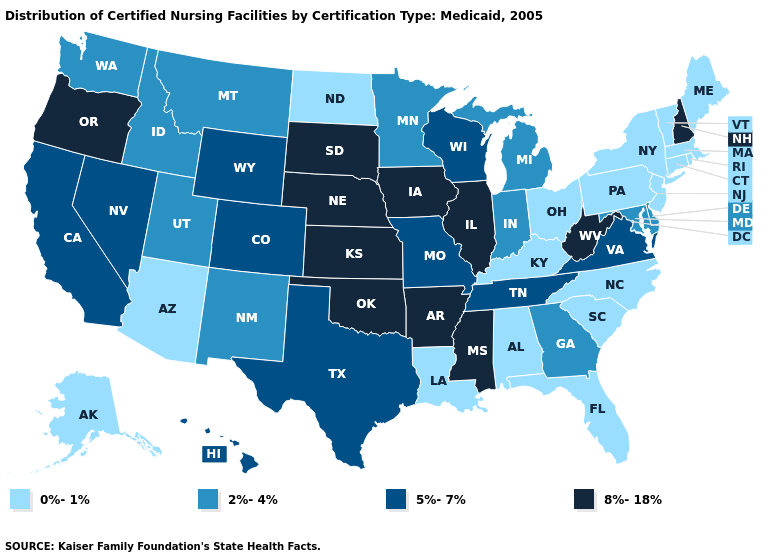Among the states that border Iowa , which have the highest value?
Write a very short answer. Illinois, Nebraska, South Dakota. Name the states that have a value in the range 5%-7%?
Short answer required. California, Colorado, Hawaii, Missouri, Nevada, Tennessee, Texas, Virginia, Wisconsin, Wyoming. Name the states that have a value in the range 8%-18%?
Quick response, please. Arkansas, Illinois, Iowa, Kansas, Mississippi, Nebraska, New Hampshire, Oklahoma, Oregon, South Dakota, West Virginia. What is the highest value in states that border Washington?
Concise answer only. 8%-18%. What is the highest value in states that border Delaware?
Be succinct. 2%-4%. Name the states that have a value in the range 2%-4%?
Write a very short answer. Delaware, Georgia, Idaho, Indiana, Maryland, Michigan, Minnesota, Montana, New Mexico, Utah, Washington. How many symbols are there in the legend?
Concise answer only. 4. Does the map have missing data?
Write a very short answer. No. What is the highest value in the MidWest ?
Concise answer only. 8%-18%. Does West Virginia have the lowest value in the South?
Write a very short answer. No. Does Oklahoma have the highest value in the USA?
Answer briefly. Yes. Name the states that have a value in the range 5%-7%?
Quick response, please. California, Colorado, Hawaii, Missouri, Nevada, Tennessee, Texas, Virginia, Wisconsin, Wyoming. What is the highest value in states that border South Dakota?
Concise answer only. 8%-18%. 